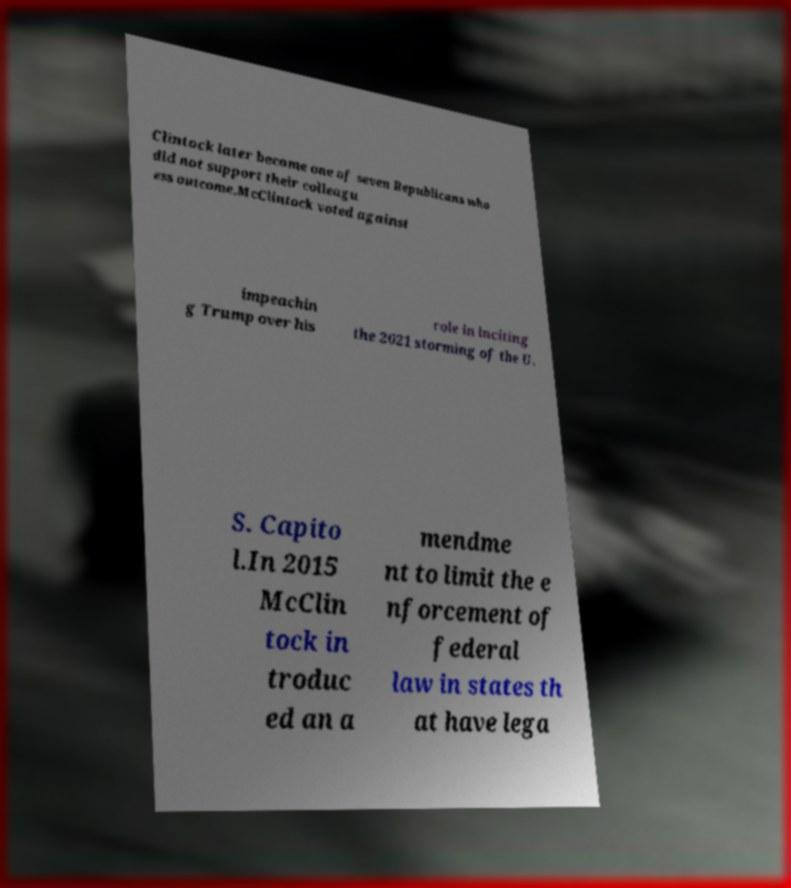Can you accurately transcribe the text from the provided image for me? Clintock later became one of seven Republicans who did not support their colleagu ess outcome.McClintock voted against impeachin g Trump over his role in inciting the 2021 storming of the U. S. Capito l.In 2015 McClin tock in troduc ed an a mendme nt to limit the e nforcement of federal law in states th at have lega 